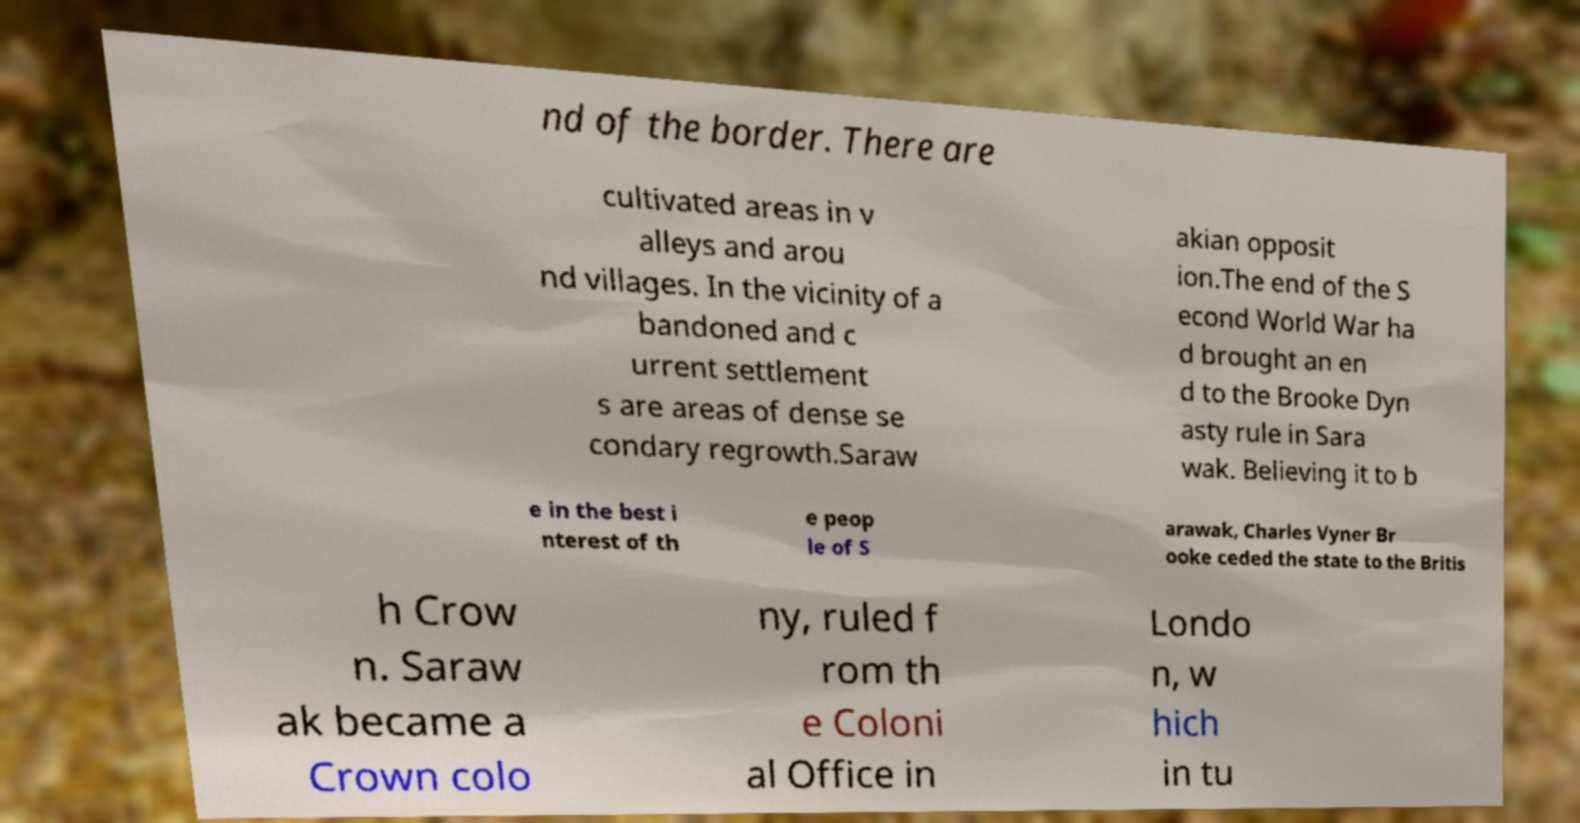What messages or text are displayed in this image? I need them in a readable, typed format. nd of the border. There are cultivated areas in v alleys and arou nd villages. In the vicinity of a bandoned and c urrent settlement s are areas of dense se condary regrowth.Saraw akian opposit ion.The end of the S econd World War ha d brought an en d to the Brooke Dyn asty rule in Sara wak. Believing it to b e in the best i nterest of th e peop le of S arawak, Charles Vyner Br ooke ceded the state to the Britis h Crow n. Saraw ak became a Crown colo ny, ruled f rom th e Coloni al Office in Londo n, w hich in tu 